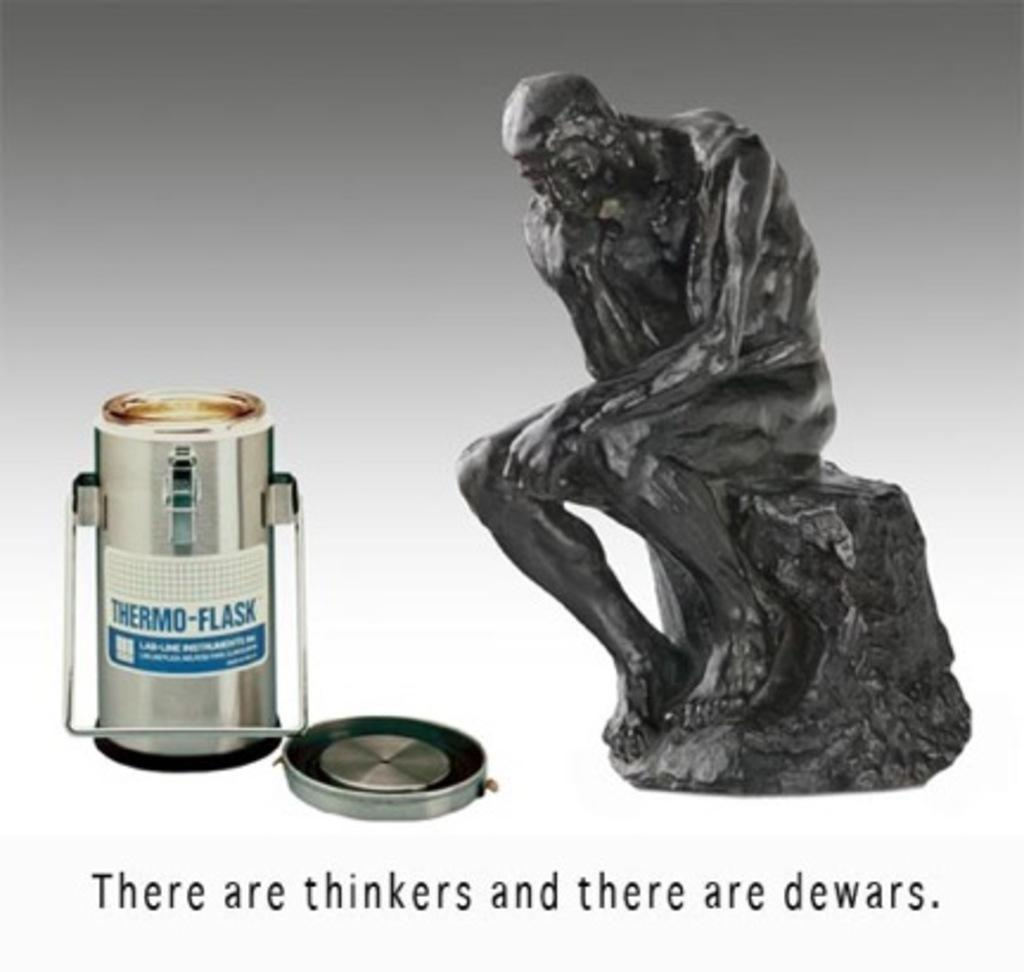What is the main subject of the image? The main subject of the image is a picture of a sculpture. Are there any other objects visible in the image? Yes, there is a thermo flask and a lid in the image. Is there any text present in the image? Yes, there is text written on the bottom of the picture. Can you see a duck using its chin to hook onto the sculpture in the image? No, there is no duck or any hooking action involving a chin in the image. 